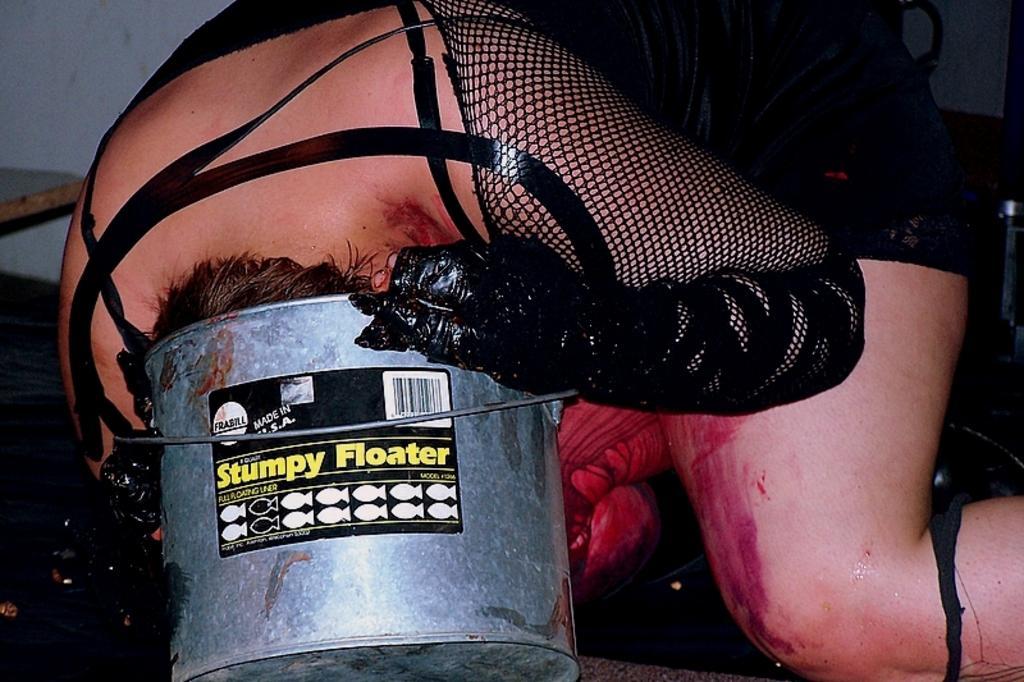Could you give a brief overview of what you see in this image? In this image, I can see a person putting head into a bucket. This person wore a black dress. I think this is a sticker, which is attached to the bucket. 